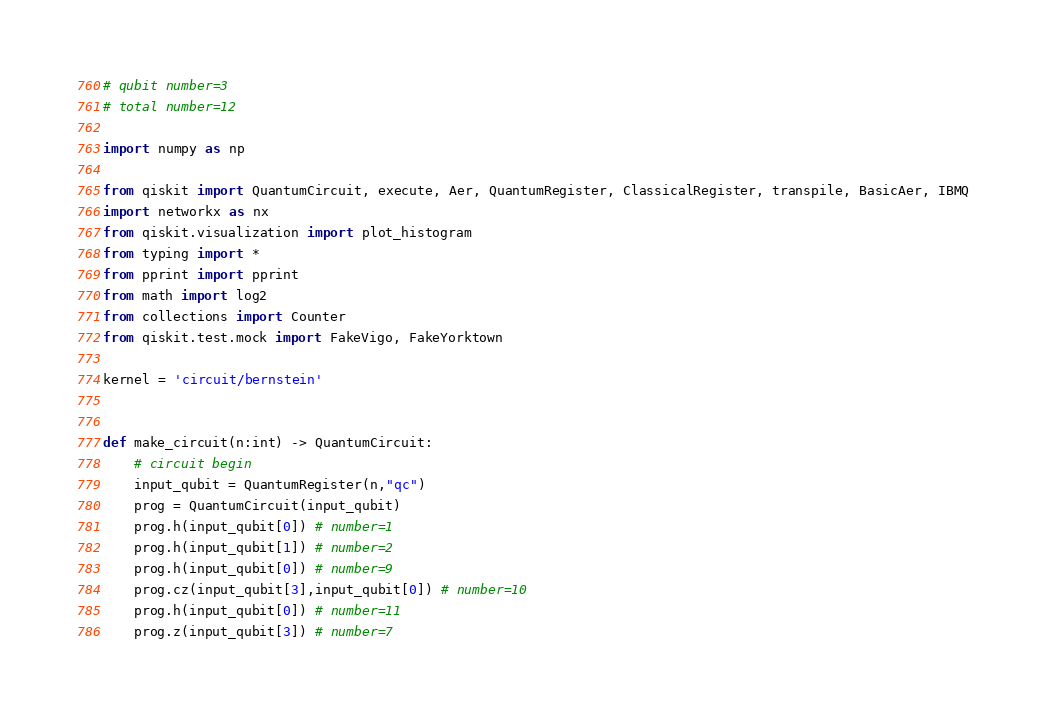Convert code to text. <code><loc_0><loc_0><loc_500><loc_500><_Python_># qubit number=3
# total number=12

import numpy as np

from qiskit import QuantumCircuit, execute, Aer, QuantumRegister, ClassicalRegister, transpile, BasicAer, IBMQ
import networkx as nx
from qiskit.visualization import plot_histogram
from typing import *
from pprint import pprint
from math import log2
from collections import Counter
from qiskit.test.mock import FakeVigo, FakeYorktown

kernel = 'circuit/bernstein'


def make_circuit(n:int) -> QuantumCircuit:
    # circuit begin
    input_qubit = QuantumRegister(n,"qc")
    prog = QuantumCircuit(input_qubit)
    prog.h(input_qubit[0]) # number=1
    prog.h(input_qubit[1]) # number=2
    prog.h(input_qubit[0]) # number=9
    prog.cz(input_qubit[3],input_qubit[0]) # number=10
    prog.h(input_qubit[0]) # number=11
    prog.z(input_qubit[3]) # number=7</code> 